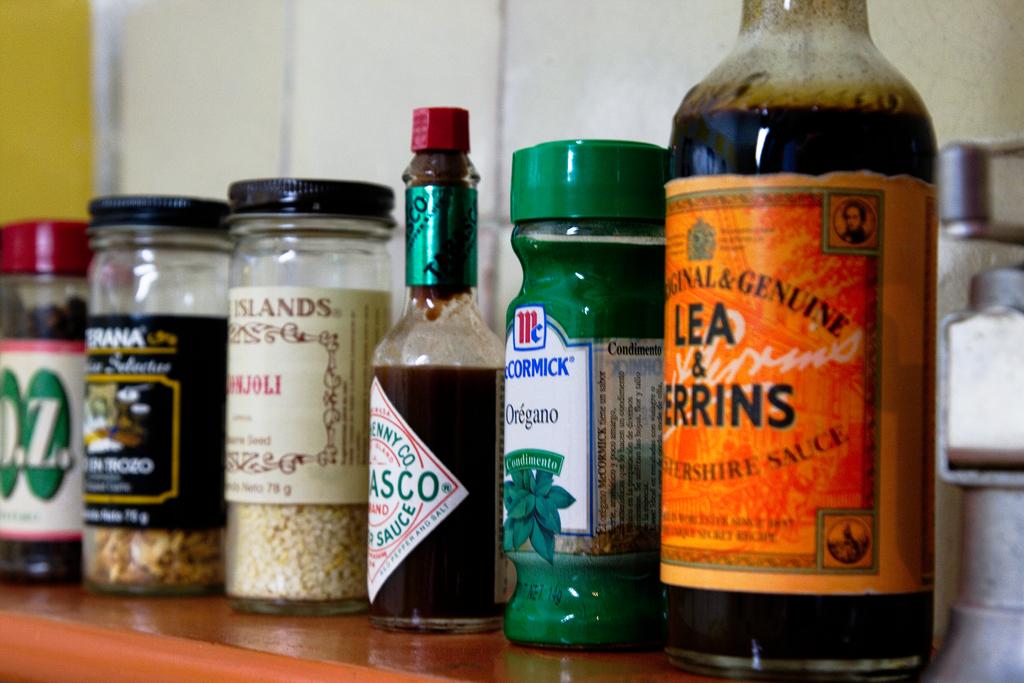What is in the green bottle?
Provide a succinct answer. Oregano. What is in the bottle closest to the camera?
Offer a very short reply. Lea & perrins. 